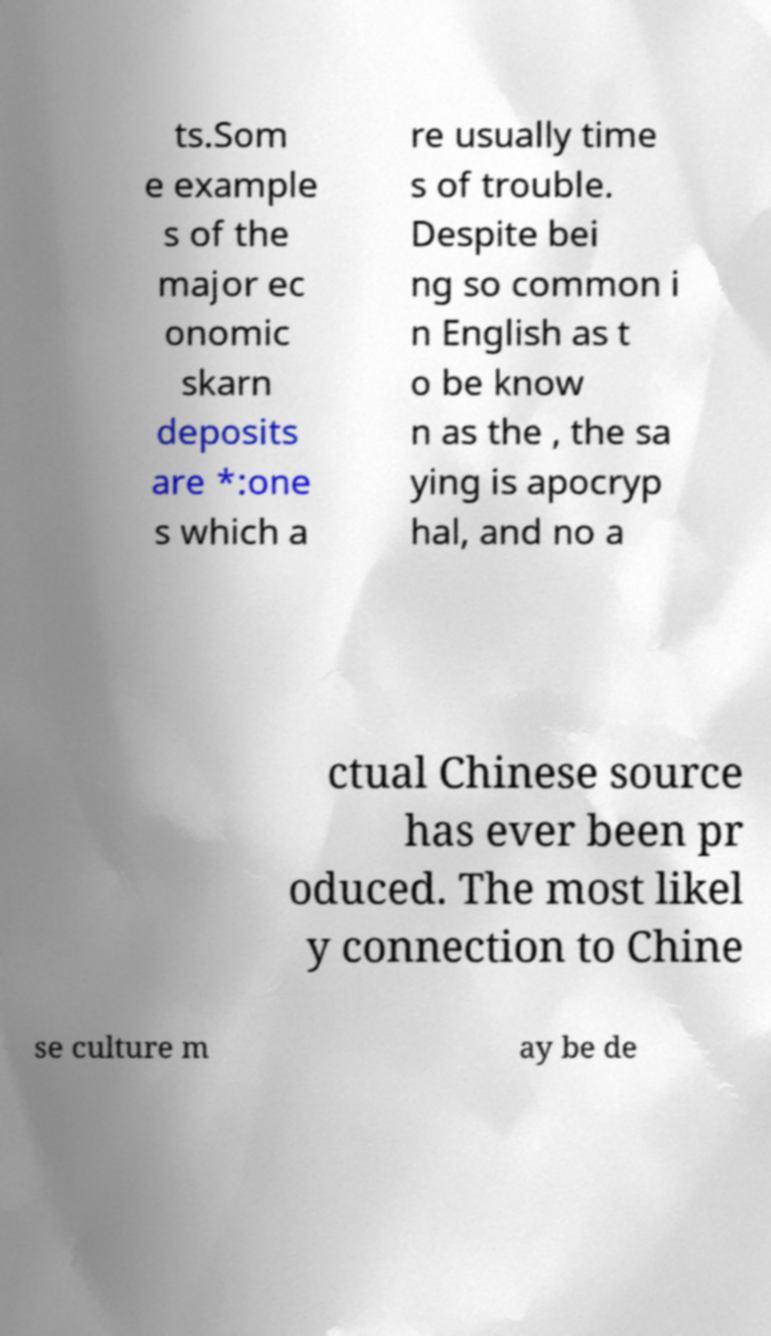There's text embedded in this image that I need extracted. Can you transcribe it verbatim? ts.Som e example s of the major ec onomic skarn deposits are *:one s which a re usually time s of trouble. Despite bei ng so common i n English as t o be know n as the , the sa ying is apocryp hal, and no a ctual Chinese source has ever been pr oduced. The most likel y connection to Chine se culture m ay be de 